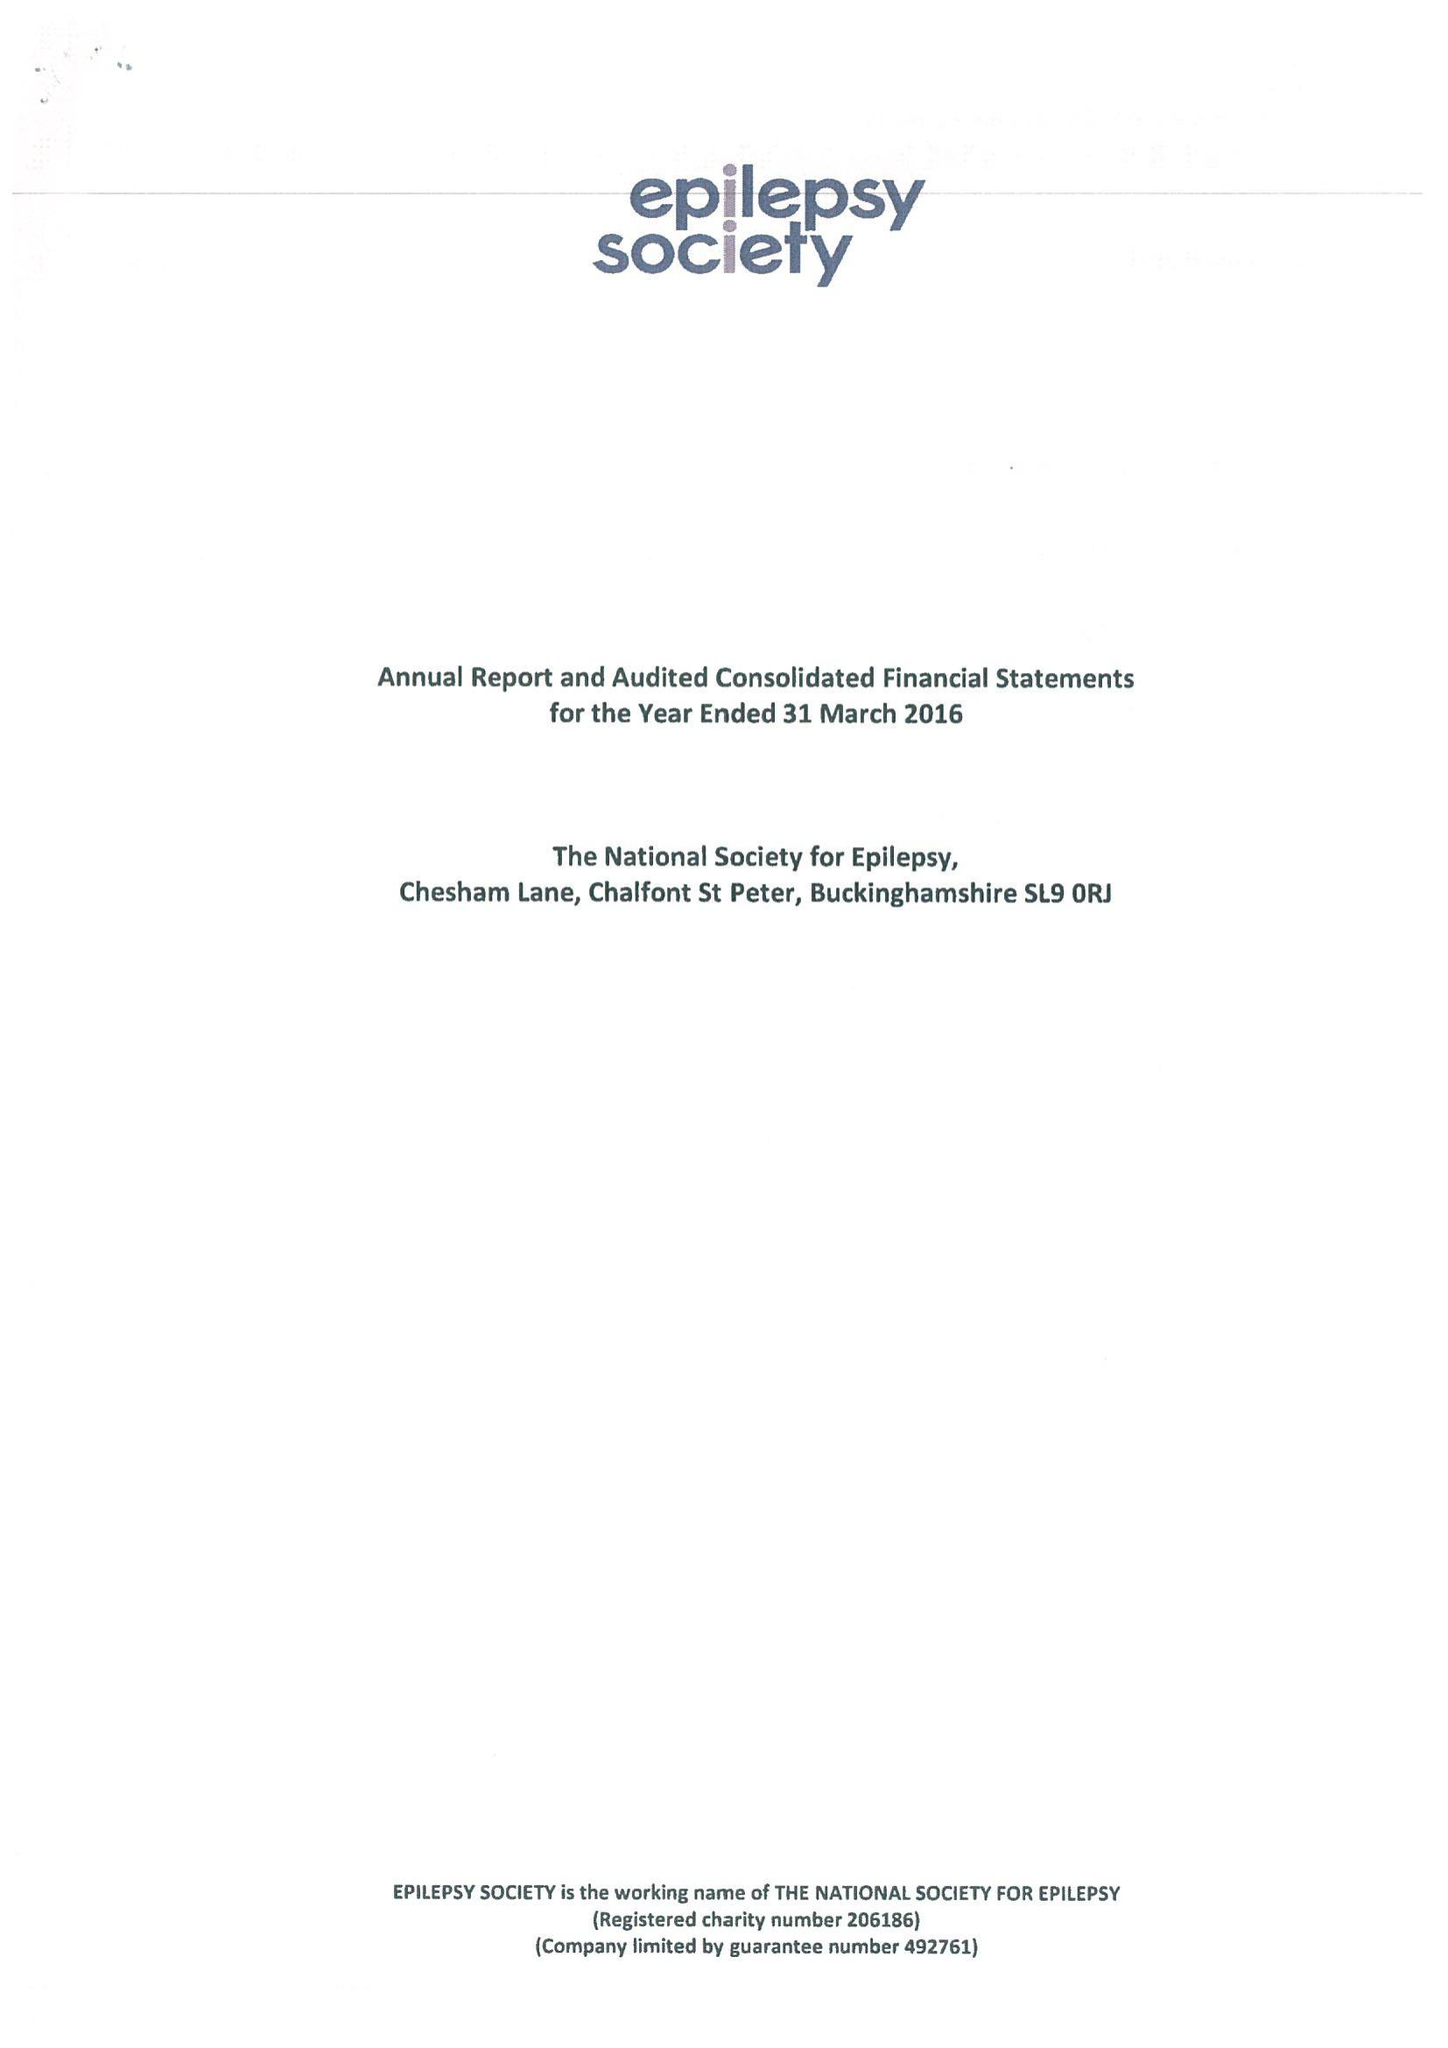What is the value for the spending_annually_in_british_pounds?
Answer the question using a single word or phrase. 18027000.00 